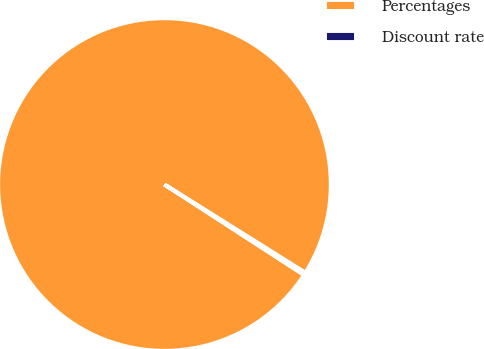<chart> <loc_0><loc_0><loc_500><loc_500><pie_chart><fcel>Percentages<fcel>Discount rate<nl><fcel>99.75%<fcel>0.25%<nl></chart> 